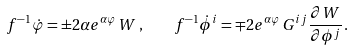Convert formula to latex. <formula><loc_0><loc_0><loc_500><loc_500>f ^ { - 1 } \dot { \varphi } = \pm 2 \alpha e ^ { \alpha \varphi } \, W \, , \quad f ^ { - 1 } \dot { \phi } ^ { i } = \mp 2 e ^ { \alpha \varphi } \, G ^ { i j } \frac { \partial W } { \partial \phi ^ { j } } \, .</formula> 